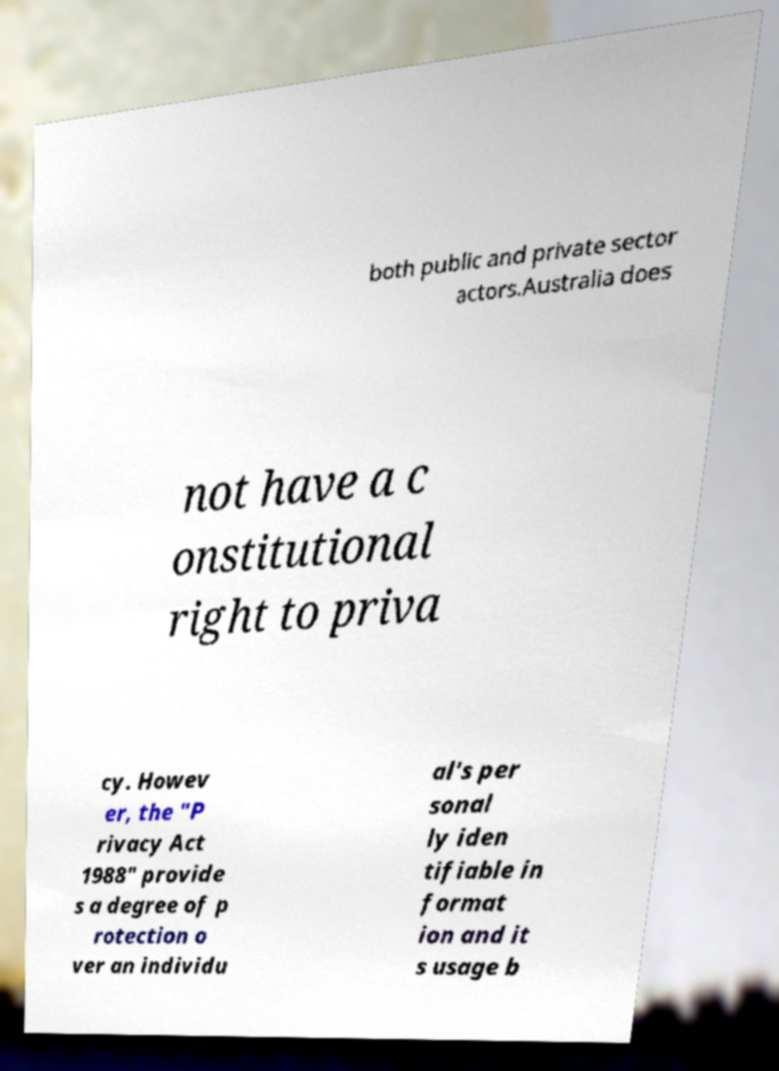There's text embedded in this image that I need extracted. Can you transcribe it verbatim? both public and private sector actors.Australia does not have a c onstitutional right to priva cy. Howev er, the "P rivacy Act 1988" provide s a degree of p rotection o ver an individu al's per sonal ly iden tifiable in format ion and it s usage b 